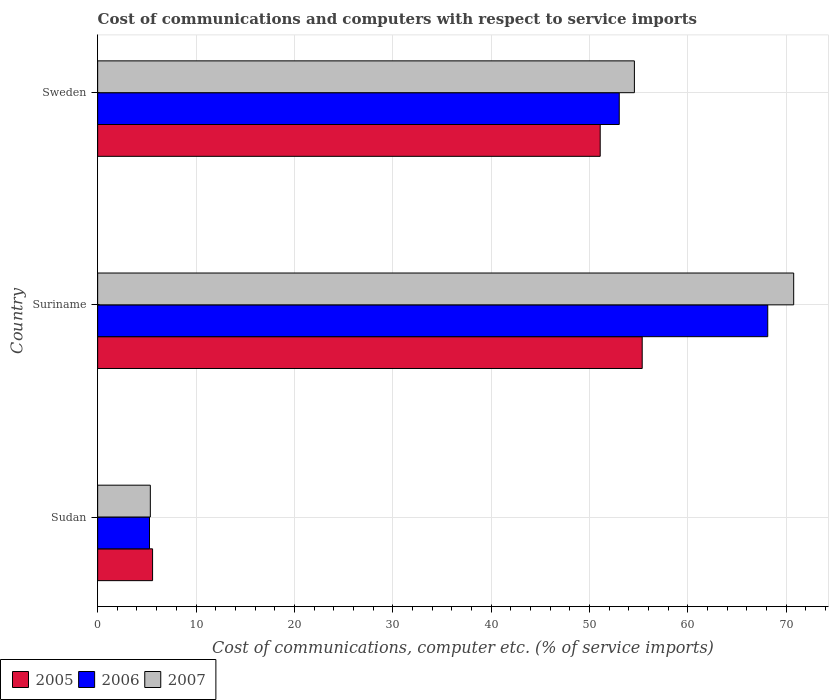How many bars are there on the 2nd tick from the top?
Ensure brevity in your answer.  3. How many bars are there on the 3rd tick from the bottom?
Give a very brief answer. 3. What is the label of the 1st group of bars from the top?
Give a very brief answer. Sweden. In how many cases, is the number of bars for a given country not equal to the number of legend labels?
Ensure brevity in your answer.  0. What is the cost of communications and computers in 2006 in Sudan?
Offer a very short reply. 5.27. Across all countries, what is the maximum cost of communications and computers in 2006?
Offer a terse response. 68.14. Across all countries, what is the minimum cost of communications and computers in 2005?
Provide a succinct answer. 5.59. In which country was the cost of communications and computers in 2006 maximum?
Keep it short and to the point. Suriname. In which country was the cost of communications and computers in 2007 minimum?
Ensure brevity in your answer.  Sudan. What is the total cost of communications and computers in 2005 in the graph?
Offer a terse response. 112.06. What is the difference between the cost of communications and computers in 2005 in Sudan and that in Sweden?
Offer a terse response. -45.52. What is the difference between the cost of communications and computers in 2006 in Sudan and the cost of communications and computers in 2007 in Sweden?
Ensure brevity in your answer.  -49.31. What is the average cost of communications and computers in 2007 per country?
Keep it short and to the point. 43.57. What is the difference between the cost of communications and computers in 2005 and cost of communications and computers in 2007 in Suriname?
Give a very brief answer. -15.4. What is the ratio of the cost of communications and computers in 2006 in Sudan to that in Suriname?
Your response must be concise. 0.08. What is the difference between the highest and the second highest cost of communications and computers in 2006?
Your answer should be very brief. 15.1. What is the difference between the highest and the lowest cost of communications and computers in 2006?
Give a very brief answer. 62.87. Are all the bars in the graph horizontal?
Ensure brevity in your answer.  Yes. What is the difference between two consecutive major ticks on the X-axis?
Keep it short and to the point. 10. Are the values on the major ticks of X-axis written in scientific E-notation?
Give a very brief answer. No. Does the graph contain grids?
Make the answer very short. Yes. Where does the legend appear in the graph?
Offer a terse response. Bottom left. What is the title of the graph?
Your answer should be compact. Cost of communications and computers with respect to service imports. Does "1976" appear as one of the legend labels in the graph?
Your answer should be very brief. No. What is the label or title of the X-axis?
Your answer should be compact. Cost of communications, computer etc. (% of service imports). What is the Cost of communications, computer etc. (% of service imports) of 2005 in Sudan?
Keep it short and to the point. 5.59. What is the Cost of communications, computer etc. (% of service imports) of 2006 in Sudan?
Your answer should be very brief. 5.27. What is the Cost of communications, computer etc. (% of service imports) in 2007 in Sudan?
Your response must be concise. 5.36. What is the Cost of communications, computer etc. (% of service imports) in 2005 in Suriname?
Ensure brevity in your answer.  55.37. What is the Cost of communications, computer etc. (% of service imports) in 2006 in Suriname?
Offer a terse response. 68.14. What is the Cost of communications, computer etc. (% of service imports) of 2007 in Suriname?
Offer a terse response. 70.78. What is the Cost of communications, computer etc. (% of service imports) in 2005 in Sweden?
Offer a terse response. 51.1. What is the Cost of communications, computer etc. (% of service imports) in 2006 in Sweden?
Ensure brevity in your answer.  53.04. What is the Cost of communications, computer etc. (% of service imports) of 2007 in Sweden?
Provide a short and direct response. 54.58. Across all countries, what is the maximum Cost of communications, computer etc. (% of service imports) in 2005?
Provide a short and direct response. 55.37. Across all countries, what is the maximum Cost of communications, computer etc. (% of service imports) of 2006?
Make the answer very short. 68.14. Across all countries, what is the maximum Cost of communications, computer etc. (% of service imports) in 2007?
Provide a succinct answer. 70.78. Across all countries, what is the minimum Cost of communications, computer etc. (% of service imports) in 2005?
Your answer should be very brief. 5.59. Across all countries, what is the minimum Cost of communications, computer etc. (% of service imports) in 2006?
Your answer should be compact. 5.27. Across all countries, what is the minimum Cost of communications, computer etc. (% of service imports) of 2007?
Give a very brief answer. 5.36. What is the total Cost of communications, computer etc. (% of service imports) in 2005 in the graph?
Offer a very short reply. 112.06. What is the total Cost of communications, computer etc. (% of service imports) of 2006 in the graph?
Provide a short and direct response. 126.45. What is the total Cost of communications, computer etc. (% of service imports) of 2007 in the graph?
Make the answer very short. 130.71. What is the difference between the Cost of communications, computer etc. (% of service imports) in 2005 in Sudan and that in Suriname?
Provide a short and direct response. -49.79. What is the difference between the Cost of communications, computer etc. (% of service imports) of 2006 in Sudan and that in Suriname?
Your answer should be compact. -62.87. What is the difference between the Cost of communications, computer etc. (% of service imports) in 2007 in Sudan and that in Suriname?
Offer a very short reply. -65.42. What is the difference between the Cost of communications, computer etc. (% of service imports) of 2005 in Sudan and that in Sweden?
Make the answer very short. -45.52. What is the difference between the Cost of communications, computer etc. (% of service imports) in 2006 in Sudan and that in Sweden?
Your answer should be very brief. -47.77. What is the difference between the Cost of communications, computer etc. (% of service imports) of 2007 in Sudan and that in Sweden?
Keep it short and to the point. -49.22. What is the difference between the Cost of communications, computer etc. (% of service imports) of 2005 in Suriname and that in Sweden?
Your response must be concise. 4.27. What is the difference between the Cost of communications, computer etc. (% of service imports) in 2006 in Suriname and that in Sweden?
Your answer should be very brief. 15.1. What is the difference between the Cost of communications, computer etc. (% of service imports) of 2007 in Suriname and that in Sweden?
Keep it short and to the point. 16.2. What is the difference between the Cost of communications, computer etc. (% of service imports) of 2005 in Sudan and the Cost of communications, computer etc. (% of service imports) of 2006 in Suriname?
Keep it short and to the point. -62.55. What is the difference between the Cost of communications, computer etc. (% of service imports) in 2005 in Sudan and the Cost of communications, computer etc. (% of service imports) in 2007 in Suriname?
Provide a short and direct response. -65.19. What is the difference between the Cost of communications, computer etc. (% of service imports) in 2006 in Sudan and the Cost of communications, computer etc. (% of service imports) in 2007 in Suriname?
Offer a very short reply. -65.5. What is the difference between the Cost of communications, computer etc. (% of service imports) of 2005 in Sudan and the Cost of communications, computer etc. (% of service imports) of 2006 in Sweden?
Make the answer very short. -47.45. What is the difference between the Cost of communications, computer etc. (% of service imports) in 2005 in Sudan and the Cost of communications, computer etc. (% of service imports) in 2007 in Sweden?
Keep it short and to the point. -48.99. What is the difference between the Cost of communications, computer etc. (% of service imports) in 2006 in Sudan and the Cost of communications, computer etc. (% of service imports) in 2007 in Sweden?
Ensure brevity in your answer.  -49.31. What is the difference between the Cost of communications, computer etc. (% of service imports) of 2005 in Suriname and the Cost of communications, computer etc. (% of service imports) of 2006 in Sweden?
Provide a short and direct response. 2.33. What is the difference between the Cost of communications, computer etc. (% of service imports) of 2005 in Suriname and the Cost of communications, computer etc. (% of service imports) of 2007 in Sweden?
Keep it short and to the point. 0.79. What is the difference between the Cost of communications, computer etc. (% of service imports) in 2006 in Suriname and the Cost of communications, computer etc. (% of service imports) in 2007 in Sweden?
Give a very brief answer. 13.56. What is the average Cost of communications, computer etc. (% of service imports) of 2005 per country?
Offer a very short reply. 37.35. What is the average Cost of communications, computer etc. (% of service imports) of 2006 per country?
Give a very brief answer. 42.15. What is the average Cost of communications, computer etc. (% of service imports) in 2007 per country?
Provide a short and direct response. 43.57. What is the difference between the Cost of communications, computer etc. (% of service imports) in 2005 and Cost of communications, computer etc. (% of service imports) in 2006 in Sudan?
Keep it short and to the point. 0.31. What is the difference between the Cost of communications, computer etc. (% of service imports) in 2005 and Cost of communications, computer etc. (% of service imports) in 2007 in Sudan?
Your answer should be very brief. 0.23. What is the difference between the Cost of communications, computer etc. (% of service imports) of 2006 and Cost of communications, computer etc. (% of service imports) of 2007 in Sudan?
Your answer should be compact. -0.08. What is the difference between the Cost of communications, computer etc. (% of service imports) in 2005 and Cost of communications, computer etc. (% of service imports) in 2006 in Suriname?
Your answer should be very brief. -12.77. What is the difference between the Cost of communications, computer etc. (% of service imports) in 2005 and Cost of communications, computer etc. (% of service imports) in 2007 in Suriname?
Ensure brevity in your answer.  -15.4. What is the difference between the Cost of communications, computer etc. (% of service imports) in 2006 and Cost of communications, computer etc. (% of service imports) in 2007 in Suriname?
Provide a succinct answer. -2.64. What is the difference between the Cost of communications, computer etc. (% of service imports) in 2005 and Cost of communications, computer etc. (% of service imports) in 2006 in Sweden?
Offer a terse response. -1.94. What is the difference between the Cost of communications, computer etc. (% of service imports) in 2005 and Cost of communications, computer etc. (% of service imports) in 2007 in Sweden?
Your response must be concise. -3.48. What is the difference between the Cost of communications, computer etc. (% of service imports) in 2006 and Cost of communications, computer etc. (% of service imports) in 2007 in Sweden?
Offer a terse response. -1.54. What is the ratio of the Cost of communications, computer etc. (% of service imports) of 2005 in Sudan to that in Suriname?
Your answer should be very brief. 0.1. What is the ratio of the Cost of communications, computer etc. (% of service imports) in 2006 in Sudan to that in Suriname?
Provide a short and direct response. 0.08. What is the ratio of the Cost of communications, computer etc. (% of service imports) in 2007 in Sudan to that in Suriname?
Provide a succinct answer. 0.08. What is the ratio of the Cost of communications, computer etc. (% of service imports) of 2005 in Sudan to that in Sweden?
Your response must be concise. 0.11. What is the ratio of the Cost of communications, computer etc. (% of service imports) in 2006 in Sudan to that in Sweden?
Your answer should be very brief. 0.1. What is the ratio of the Cost of communications, computer etc. (% of service imports) of 2007 in Sudan to that in Sweden?
Give a very brief answer. 0.1. What is the ratio of the Cost of communications, computer etc. (% of service imports) in 2005 in Suriname to that in Sweden?
Provide a short and direct response. 1.08. What is the ratio of the Cost of communications, computer etc. (% of service imports) in 2006 in Suriname to that in Sweden?
Give a very brief answer. 1.28. What is the ratio of the Cost of communications, computer etc. (% of service imports) of 2007 in Suriname to that in Sweden?
Provide a short and direct response. 1.3. What is the difference between the highest and the second highest Cost of communications, computer etc. (% of service imports) of 2005?
Your answer should be very brief. 4.27. What is the difference between the highest and the second highest Cost of communications, computer etc. (% of service imports) in 2006?
Ensure brevity in your answer.  15.1. What is the difference between the highest and the second highest Cost of communications, computer etc. (% of service imports) of 2007?
Provide a succinct answer. 16.2. What is the difference between the highest and the lowest Cost of communications, computer etc. (% of service imports) of 2005?
Your answer should be very brief. 49.79. What is the difference between the highest and the lowest Cost of communications, computer etc. (% of service imports) of 2006?
Provide a succinct answer. 62.87. What is the difference between the highest and the lowest Cost of communications, computer etc. (% of service imports) of 2007?
Your answer should be compact. 65.42. 